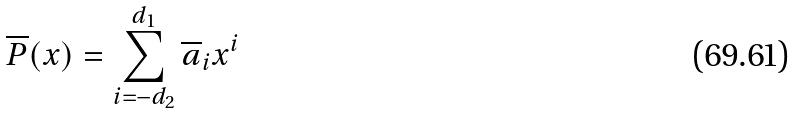<formula> <loc_0><loc_0><loc_500><loc_500>\overline { P } ( x ) = \sum _ { i = - d _ { 2 } } ^ { d _ { 1 } } \overline { a } _ { i } x ^ { i }</formula> 